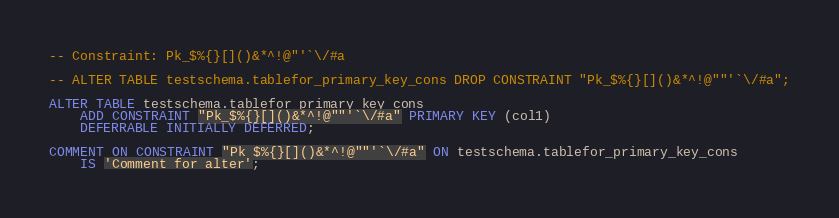Convert code to text. <code><loc_0><loc_0><loc_500><loc_500><_SQL_>-- Constraint: Pk_$%{}[]()&*^!@"'`\/#a

-- ALTER TABLE testschema.tablefor_primary_key_cons DROP CONSTRAINT "Pk_$%{}[]()&*^!@""'`\/#a";

ALTER TABLE testschema.tablefor_primary_key_cons
    ADD CONSTRAINT "Pk_$%{}[]()&*^!@""'`\/#a" PRIMARY KEY (col1)
    DEFERRABLE INITIALLY DEFERRED;

COMMENT ON CONSTRAINT "Pk_$%{}[]()&*^!@""'`\/#a" ON testschema.tablefor_primary_key_cons
    IS 'Comment for alter';

</code> 